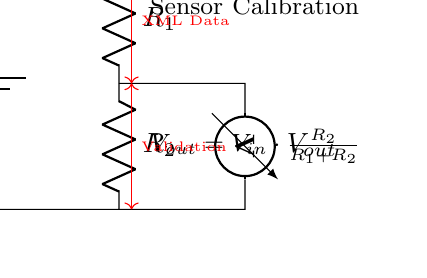What is the purpose of this circuit? The purpose of this circuit is to create a voltage divider for sensor calibration. This is indicated by the label on the right side of the circuit diagram.
Answer: Voltage divider for sensor calibration What is the formula for the output voltage? The output voltage formula is provided as \( V_{out} = V_{in} \cdot \frac{R_2}{R_1 + R_2} \). This equation calculates the voltage across R2 relative to the total resistance.
Answer: Vout = Vin * R2/(R1 + R2) What are the components in this circuit? The circuit contains a battery, two resistors (R1 and R2), and a voltmeter. These components are visually represented in the schematic.
Answer: Battery, R1, R2, voltmeter What do the red arrows indicate? The red arrows indicate the flow of XML data and validation through the circuit, suggesting a connection to digital systems for accurate sensor readings.
Answer: XML Data and Validation Which resistor affects the output voltage more significantly when increased? Increasing R2 increases the output voltage according to the voltage divider formula; thus, R2 has a more significant effect on Vout.
Answer: R2 What is the symbol for the voltmeter in this circuit? The voltmeter is represented by a specific icon in the circuit diagram that includes two parallel lines, indicating measurement.
Answer: Voltmeter What does the voltage divider depend on? The voltage divider depends on the values of R1 and R2 as well as the input voltage (Vin). These are the critical parameters that determine the output voltage (Vout).
Answer: R1, R2, Vin 